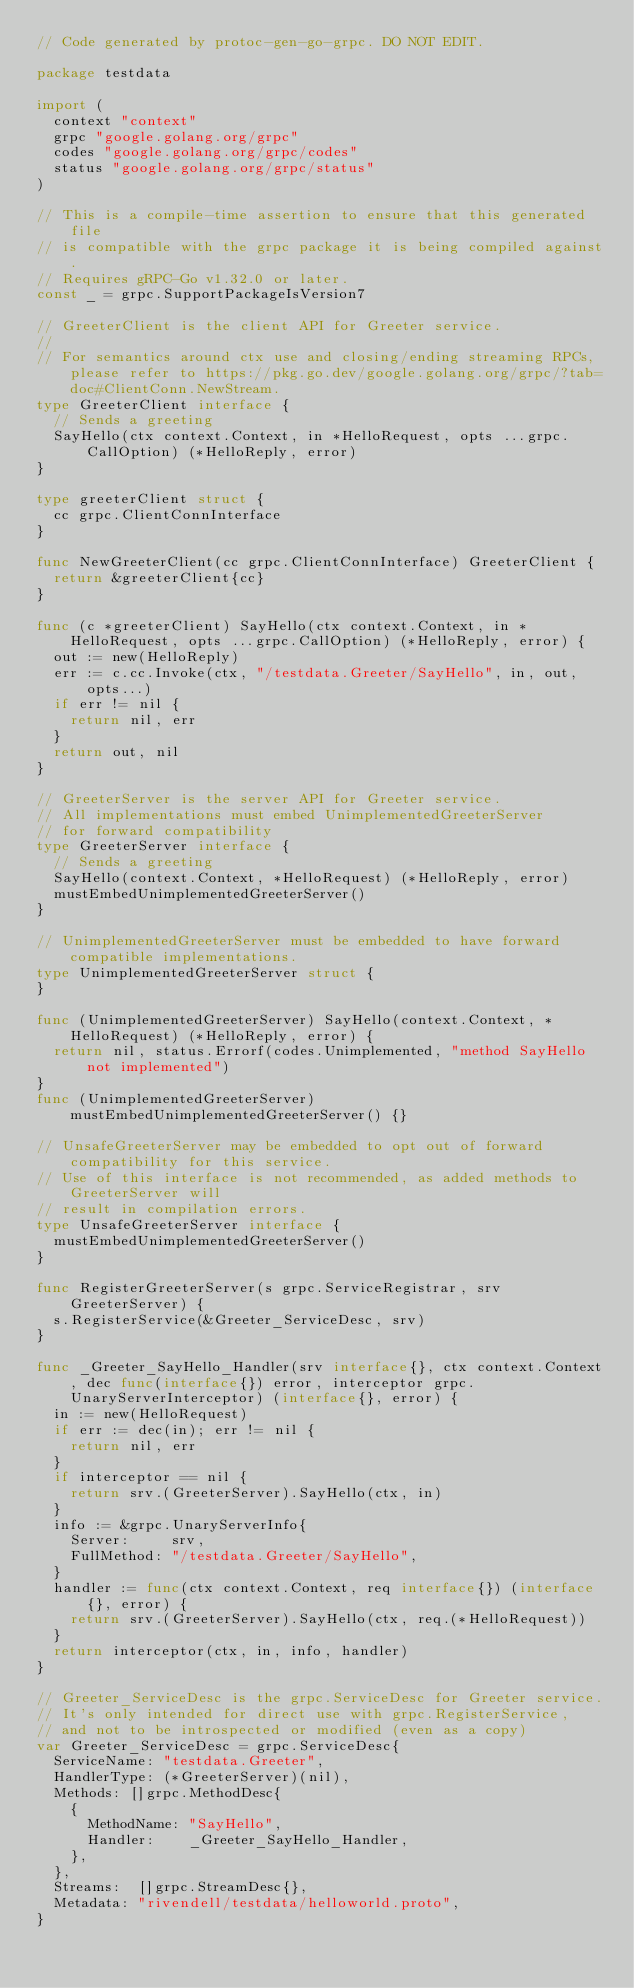Convert code to text. <code><loc_0><loc_0><loc_500><loc_500><_Go_>// Code generated by protoc-gen-go-grpc. DO NOT EDIT.

package testdata

import (
	context "context"
	grpc "google.golang.org/grpc"
	codes "google.golang.org/grpc/codes"
	status "google.golang.org/grpc/status"
)

// This is a compile-time assertion to ensure that this generated file
// is compatible with the grpc package it is being compiled against.
// Requires gRPC-Go v1.32.0 or later.
const _ = grpc.SupportPackageIsVersion7

// GreeterClient is the client API for Greeter service.
//
// For semantics around ctx use and closing/ending streaming RPCs, please refer to https://pkg.go.dev/google.golang.org/grpc/?tab=doc#ClientConn.NewStream.
type GreeterClient interface {
	// Sends a greeting
	SayHello(ctx context.Context, in *HelloRequest, opts ...grpc.CallOption) (*HelloReply, error)
}

type greeterClient struct {
	cc grpc.ClientConnInterface
}

func NewGreeterClient(cc grpc.ClientConnInterface) GreeterClient {
	return &greeterClient{cc}
}

func (c *greeterClient) SayHello(ctx context.Context, in *HelloRequest, opts ...grpc.CallOption) (*HelloReply, error) {
	out := new(HelloReply)
	err := c.cc.Invoke(ctx, "/testdata.Greeter/SayHello", in, out, opts...)
	if err != nil {
		return nil, err
	}
	return out, nil
}

// GreeterServer is the server API for Greeter service.
// All implementations must embed UnimplementedGreeterServer
// for forward compatibility
type GreeterServer interface {
	// Sends a greeting
	SayHello(context.Context, *HelloRequest) (*HelloReply, error)
	mustEmbedUnimplementedGreeterServer()
}

// UnimplementedGreeterServer must be embedded to have forward compatible implementations.
type UnimplementedGreeterServer struct {
}

func (UnimplementedGreeterServer) SayHello(context.Context, *HelloRequest) (*HelloReply, error) {
	return nil, status.Errorf(codes.Unimplemented, "method SayHello not implemented")
}
func (UnimplementedGreeterServer) mustEmbedUnimplementedGreeterServer() {}

// UnsafeGreeterServer may be embedded to opt out of forward compatibility for this service.
// Use of this interface is not recommended, as added methods to GreeterServer will
// result in compilation errors.
type UnsafeGreeterServer interface {
	mustEmbedUnimplementedGreeterServer()
}

func RegisterGreeterServer(s grpc.ServiceRegistrar, srv GreeterServer) {
	s.RegisterService(&Greeter_ServiceDesc, srv)
}

func _Greeter_SayHello_Handler(srv interface{}, ctx context.Context, dec func(interface{}) error, interceptor grpc.UnaryServerInterceptor) (interface{}, error) {
	in := new(HelloRequest)
	if err := dec(in); err != nil {
		return nil, err
	}
	if interceptor == nil {
		return srv.(GreeterServer).SayHello(ctx, in)
	}
	info := &grpc.UnaryServerInfo{
		Server:     srv,
		FullMethod: "/testdata.Greeter/SayHello",
	}
	handler := func(ctx context.Context, req interface{}) (interface{}, error) {
		return srv.(GreeterServer).SayHello(ctx, req.(*HelloRequest))
	}
	return interceptor(ctx, in, info, handler)
}

// Greeter_ServiceDesc is the grpc.ServiceDesc for Greeter service.
// It's only intended for direct use with grpc.RegisterService,
// and not to be introspected or modified (even as a copy)
var Greeter_ServiceDesc = grpc.ServiceDesc{
	ServiceName: "testdata.Greeter",
	HandlerType: (*GreeterServer)(nil),
	Methods: []grpc.MethodDesc{
		{
			MethodName: "SayHello",
			Handler:    _Greeter_SayHello_Handler,
		},
	},
	Streams:  []grpc.StreamDesc{},
	Metadata: "rivendell/testdata/helloworld.proto",
}
</code> 